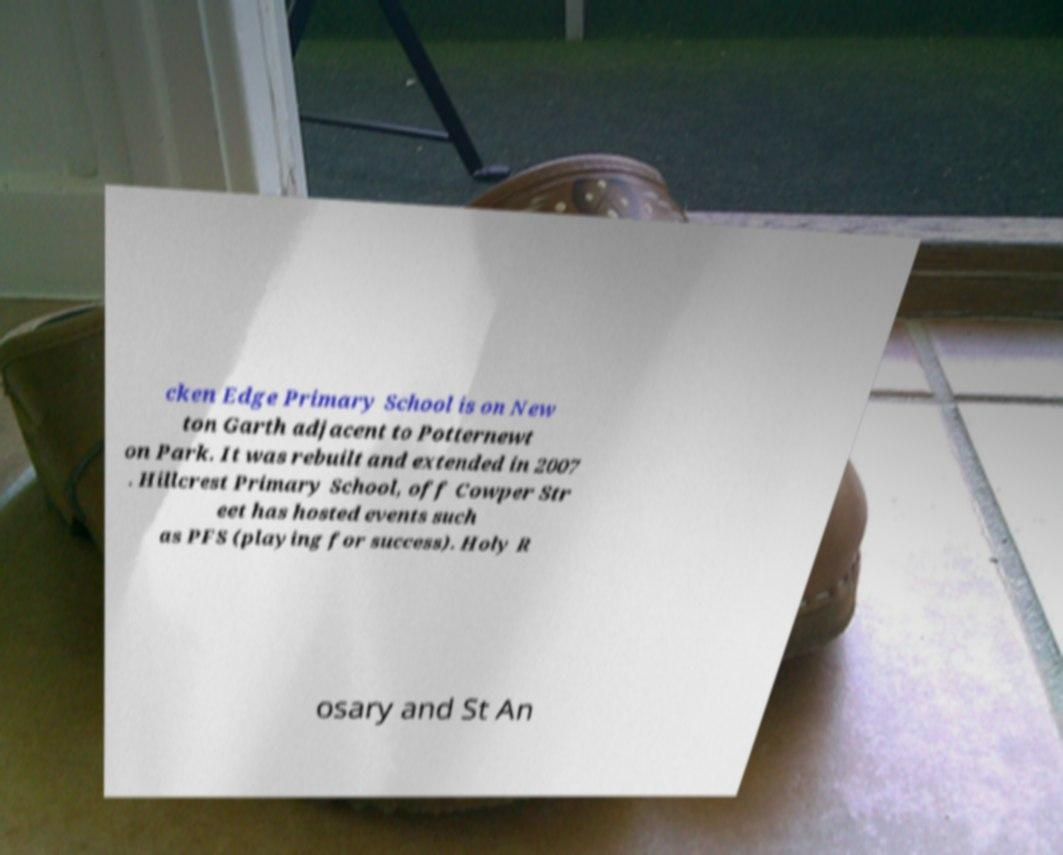Can you read and provide the text displayed in the image?This photo seems to have some interesting text. Can you extract and type it out for me? cken Edge Primary School is on New ton Garth adjacent to Potternewt on Park. It was rebuilt and extended in 2007 . Hillcrest Primary School, off Cowper Str eet has hosted events such as PFS (playing for success). Holy R osary and St An 